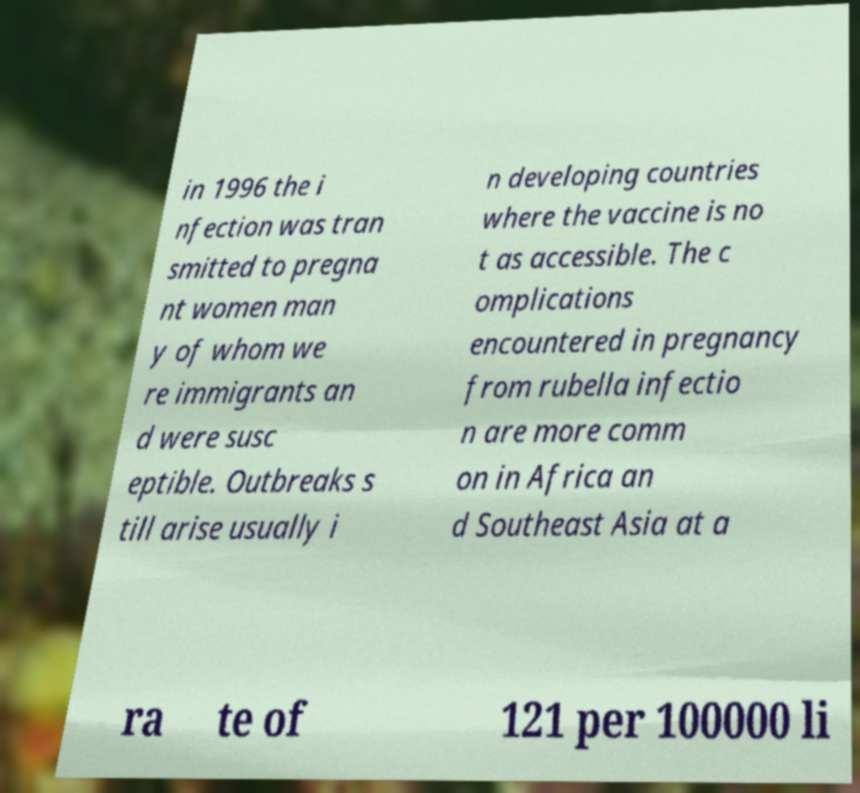For documentation purposes, I need the text within this image transcribed. Could you provide that? in 1996 the i nfection was tran smitted to pregna nt women man y of whom we re immigrants an d were susc eptible. Outbreaks s till arise usually i n developing countries where the vaccine is no t as accessible. The c omplications encountered in pregnancy from rubella infectio n are more comm on in Africa an d Southeast Asia at a ra te of 121 per 100000 li 